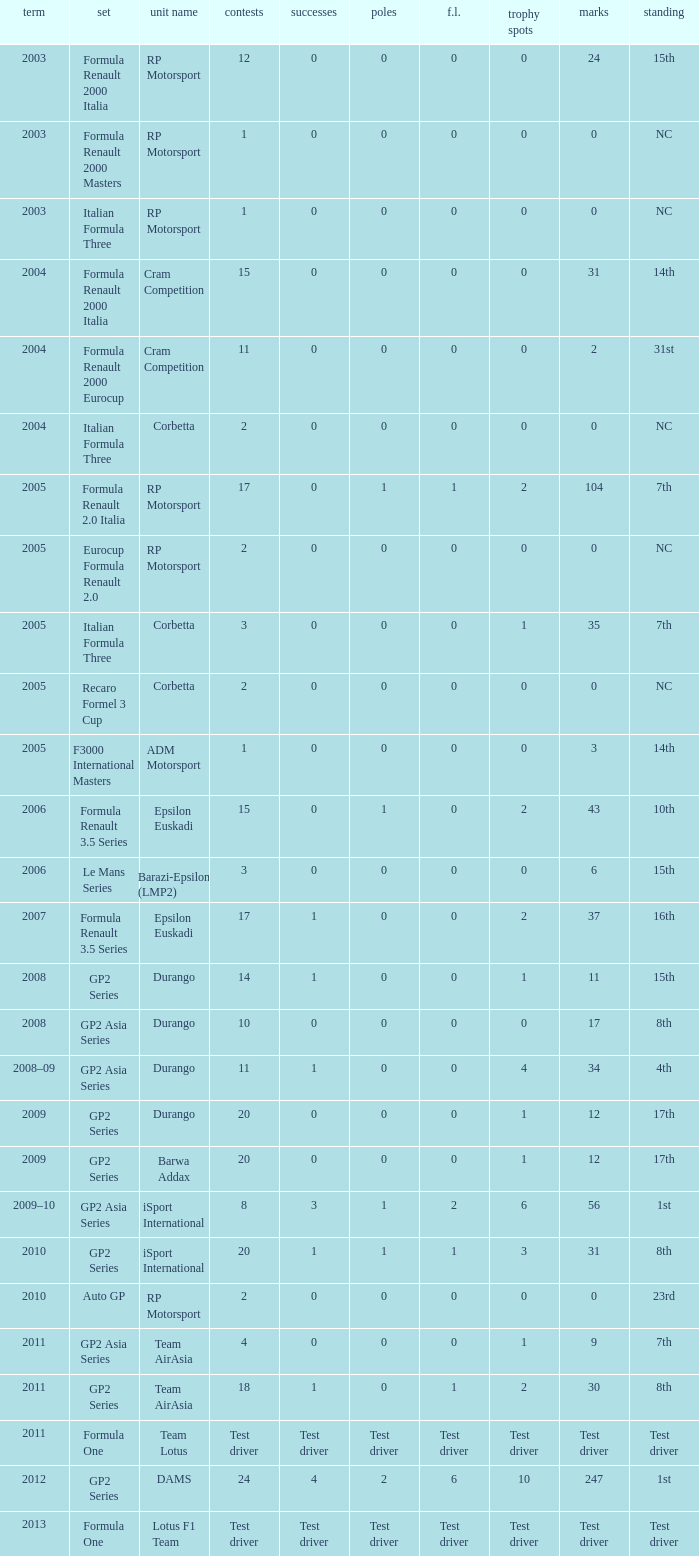What is the number of podiums with 0 wins and 6 points? 0.0. Can you give me this table as a dict? {'header': ['term', 'set', 'unit name', 'contests', 'successes', 'poles', 'f.l.', 'trophy spots', 'marks', 'standing'], 'rows': [['2003', 'Formula Renault 2000 Italia', 'RP Motorsport', '12', '0', '0', '0', '0', '24', '15th'], ['2003', 'Formula Renault 2000 Masters', 'RP Motorsport', '1', '0', '0', '0', '0', '0', 'NC'], ['2003', 'Italian Formula Three', 'RP Motorsport', '1', '0', '0', '0', '0', '0', 'NC'], ['2004', 'Formula Renault 2000 Italia', 'Cram Competition', '15', '0', '0', '0', '0', '31', '14th'], ['2004', 'Formula Renault 2000 Eurocup', 'Cram Competition', '11', '0', '0', '0', '0', '2', '31st'], ['2004', 'Italian Formula Three', 'Corbetta', '2', '0', '0', '0', '0', '0', 'NC'], ['2005', 'Formula Renault 2.0 Italia', 'RP Motorsport', '17', '0', '1', '1', '2', '104', '7th'], ['2005', 'Eurocup Formula Renault 2.0', 'RP Motorsport', '2', '0', '0', '0', '0', '0', 'NC'], ['2005', 'Italian Formula Three', 'Corbetta', '3', '0', '0', '0', '1', '35', '7th'], ['2005', 'Recaro Formel 3 Cup', 'Corbetta', '2', '0', '0', '0', '0', '0', 'NC'], ['2005', 'F3000 International Masters', 'ADM Motorsport', '1', '0', '0', '0', '0', '3', '14th'], ['2006', 'Formula Renault 3.5 Series', 'Epsilon Euskadi', '15', '0', '1', '0', '2', '43', '10th'], ['2006', 'Le Mans Series', 'Barazi-Epsilon (LMP2)', '3', '0', '0', '0', '0', '6', '15th'], ['2007', 'Formula Renault 3.5 Series', 'Epsilon Euskadi', '17', '1', '0', '0', '2', '37', '16th'], ['2008', 'GP2 Series', 'Durango', '14', '1', '0', '0', '1', '11', '15th'], ['2008', 'GP2 Asia Series', 'Durango', '10', '0', '0', '0', '0', '17', '8th'], ['2008–09', 'GP2 Asia Series', 'Durango', '11', '1', '0', '0', '4', '34', '4th'], ['2009', 'GP2 Series', 'Durango', '20', '0', '0', '0', '1', '12', '17th'], ['2009', 'GP2 Series', 'Barwa Addax', '20', '0', '0', '0', '1', '12', '17th'], ['2009–10', 'GP2 Asia Series', 'iSport International', '8', '3', '1', '2', '6', '56', '1st'], ['2010', 'GP2 Series', 'iSport International', '20', '1', '1', '1', '3', '31', '8th'], ['2010', 'Auto GP', 'RP Motorsport', '2', '0', '0', '0', '0', '0', '23rd'], ['2011', 'GP2 Asia Series', 'Team AirAsia', '4', '0', '0', '0', '1', '9', '7th'], ['2011', 'GP2 Series', 'Team AirAsia', '18', '1', '0', '1', '2', '30', '8th'], ['2011', 'Formula One', 'Team Lotus', 'Test driver', 'Test driver', 'Test driver', 'Test driver', 'Test driver', 'Test driver', 'Test driver'], ['2012', 'GP2 Series', 'DAMS', '24', '4', '2', '6', '10', '247', '1st'], ['2013', 'Formula One', 'Lotus F1 Team', 'Test driver', 'Test driver', 'Test driver', 'Test driver', 'Test driver', 'Test driver', 'Test driver']]} 